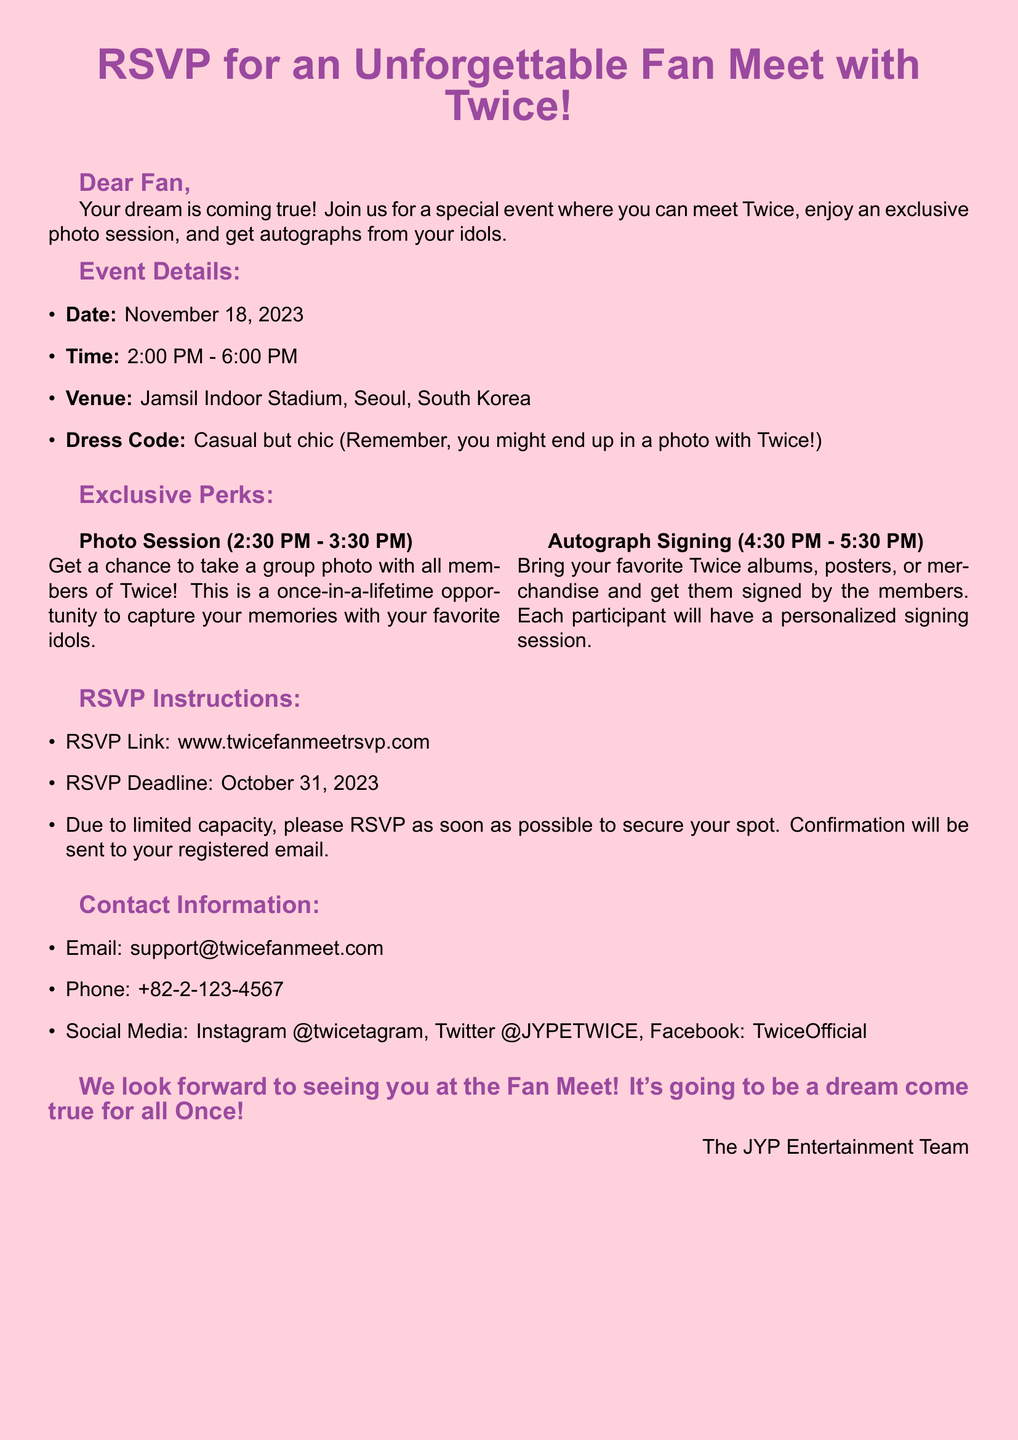What is the date of the event? The date of the event is explicitly mentioned in the document as November 18, 2023.
Answer: November 18, 2023 What is the time of the event? The time of the event is stated in the document as 2:00 PM - 6:00 PM.
Answer: 2:00 PM - 6:00 PM Where is the venue located? The document specifies the venue as Jamsil Indoor Stadium, Seoul, South Korea.
Answer: Jamsil Indoor Stadium, Seoul, South Korea What type of session will be held at 2:30 PM? The document mentions that a photo session will take place during this time.
Answer: Photo Session What is one item participants should bring for the autograph signing? The document suggests bringing favorite Twice albums, posters, or merchandise for signing.
Answer: Albums, posters, or merchandise What is the RSVP deadline? The RSVP deadline is clearly listed in the document as October 31, 2023.
Answer: October 31, 2023 How can participants confirm their RSVP? Confirmation of the RSVP will be sent to the registered email of the participants, as stated in the document.
Answer: Registered email What is the dress code for the event? The document indicates that attendees should dress casual but chic for the event.
Answer: Casual but chic What type of event is this document for? The document is specifically for an RSVP for a fan meet event with Twice.
Answer: Fan meet event 